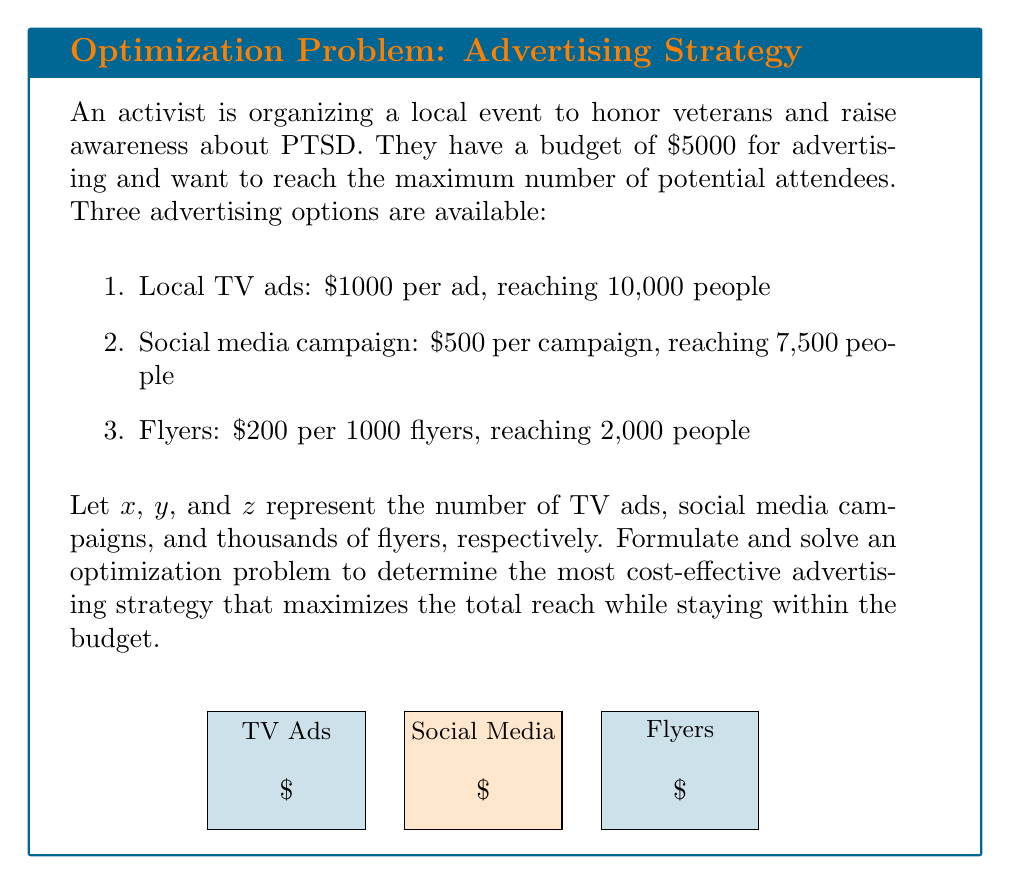Could you help me with this problem? Let's approach this step-by-step:

1) First, we need to formulate the objective function and constraints:

   Objective function (maximize reach): 
   $$10000x + 7500y + 2000z$$

   Budget constraint:
   $$1000x + 500y + 200z \leq 5000$$

   Non-negativity constraints:
   $$x, y, z \geq 0$$
   $$x, y, z \in \mathbb{Z}$$ (integer constraint)

2) This is an integer linear programming problem. We can solve it using the simplex method and then round down to the nearest integer.

3) Let's set up the initial simplex tableau:

   $$\begin{array}{c|cccc|c}
   & x & y & z & s & RHS \\
   \hline
   s & 1000 & 500 & 200 & 1 & 5000 \\
   \hline
   -Z & -10000 & -7500 & -2000 & 0 & 0
   \end{array}$$

   where $s$ is the slack variable.

4) After applying the simplex method, we get the optimal solution:
   $x = 0$, $y = 10$, $z = 0$

5) This solution suggests using 10 social media campaigns, reaching 75,000 people.

6) However, we need to check if we can improve this by using the remaining budget on flyers:

   Remaining budget = $5000 - (10 * 500) = 0$

   There's no budget left for flyers.

7) Therefore, the optimal integer solution is:
   $x = 0$ (TV ads)
   $y = 10$ (social media campaigns)
   $z = 0$ (thousands of flyers)

This strategy will reach 75,000 people, which is the maximum possible within the given budget.
Answer: 10 social media campaigns 